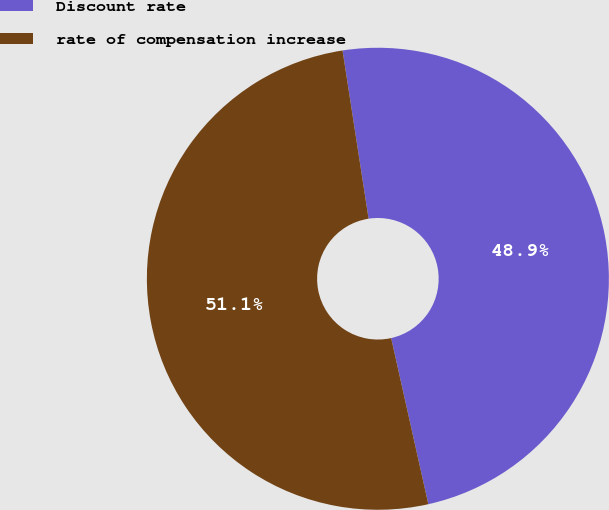Convert chart. <chart><loc_0><loc_0><loc_500><loc_500><pie_chart><fcel>Discount rate<fcel>rate of compensation increase<nl><fcel>48.94%<fcel>51.06%<nl></chart> 